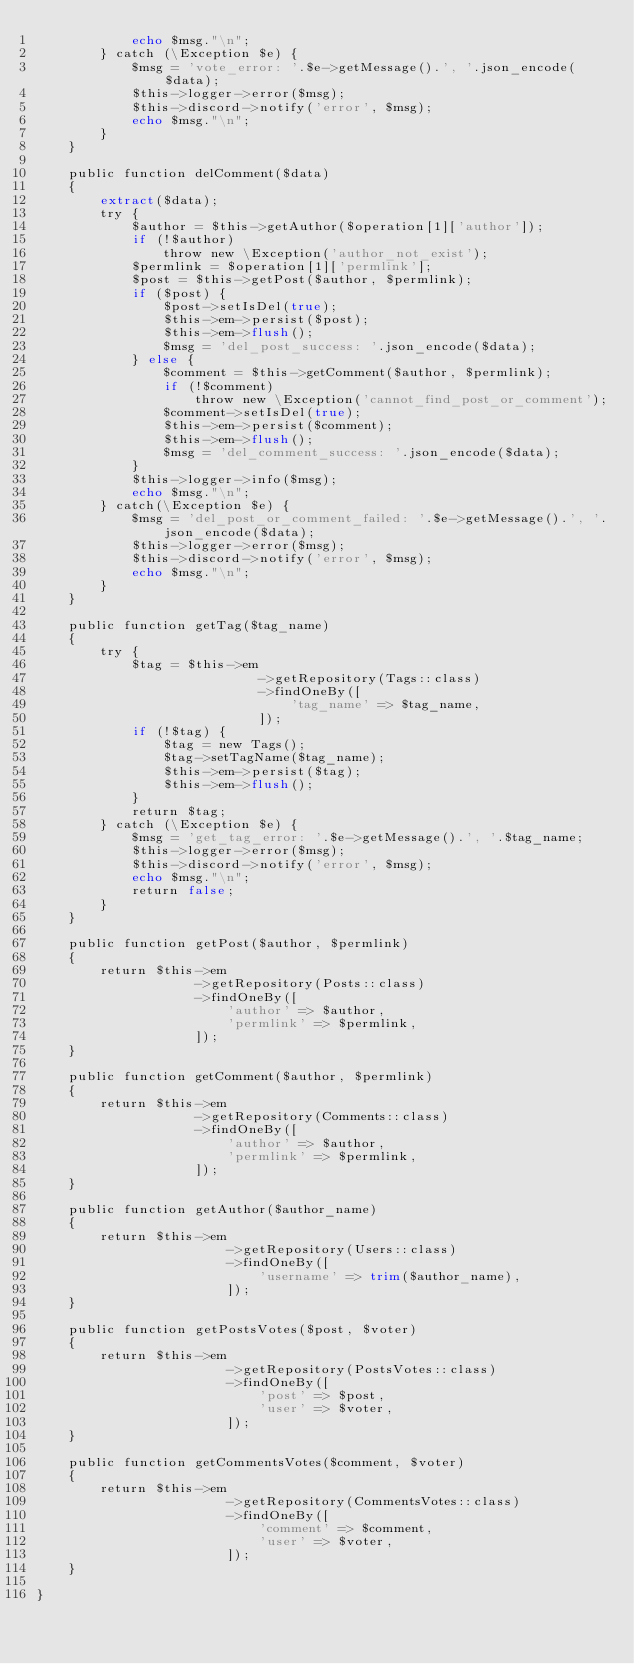Convert code to text. <code><loc_0><loc_0><loc_500><loc_500><_PHP_>            echo $msg."\n";
        } catch (\Exception $e) {
            $msg = 'vote_error: '.$e->getMessage().', '.json_encode($data);
            $this->logger->error($msg);
            $this->discord->notify('error', $msg);
            echo $msg."\n";
        }
    }

    public function delComment($data)
    {
        extract($data);
        try {
            $author = $this->getAuthor($operation[1]['author']);
            if (!$author)
                throw new \Exception('author_not_exist');
            $permlink = $operation[1]['permlink'];
            $post = $this->getPost($author, $permlink);
            if ($post) {
                $post->setIsDel(true);
                $this->em->persist($post);
                $this->em->flush();
                $msg = 'del_post_success: '.json_encode($data);
            } else {
                $comment = $this->getComment($author, $permlink);
                if (!$comment)
                    throw new \Exception('cannot_find_post_or_comment');
                $comment->setIsDel(true);
                $this->em->persist($comment);
                $this->em->flush();
                $msg = 'del_comment_success: '.json_encode($data);
            }
            $this->logger->info($msg);
            echo $msg."\n";
        } catch(\Exception $e) {
            $msg = 'del_post_or_comment_failed: '.$e->getMessage().', '.json_encode($data);
            $this->logger->error($msg);
            $this->discord->notify('error', $msg);
            echo $msg."\n";
        }
    }

    public function getTag($tag_name)
    {
        try {
            $tag = $this->em
                            ->getRepository(Tags::class)
                            ->findOneBy([
                                'tag_name' => $tag_name,
                            ]);
            if (!$tag) {
                $tag = new Tags();
                $tag->setTagName($tag_name);
                $this->em->persist($tag);
                $this->em->flush();
            }
            return $tag;
        } catch (\Exception $e) {
            $msg = 'get_tag_error: '.$e->getMessage().', '.$tag_name;
            $this->logger->error($msg);
            $this->discord->notify('error', $msg);
            echo $msg."\n";
            return false;
        }
    }

    public function getPost($author, $permlink)
    {
        return $this->em
                    ->getRepository(Posts::class)
                    ->findOneBy([
                        'author' => $author,
                        'permlink' => $permlink,
                    ]);
    }

    public function getComment($author, $permlink)
    {
        return $this->em
                    ->getRepository(Comments::class)
                    ->findOneBy([
                        'author' => $author,
                        'permlink' => $permlink,
                    ]);
    }

    public function getAuthor($author_name)
    {
        return $this->em
                        ->getRepository(Users::class)
                        ->findOneBy([
                            'username' => trim($author_name),
                        ]);
    }
    
    public function getPostsVotes($post, $voter)
    {
        return $this->em
                        ->getRepository(PostsVotes::class)
                        ->findOneBy([
                            'post' => $post,
                            'user' => $voter,
                        ]);
    }

    public function getCommentsVotes($comment, $voter)
    {
        return $this->em
                        ->getRepository(CommentsVotes::class)
                        ->findOneBy([
                            'comment' => $comment,
                            'user' => $voter,
                        ]);
    }

}
</code> 